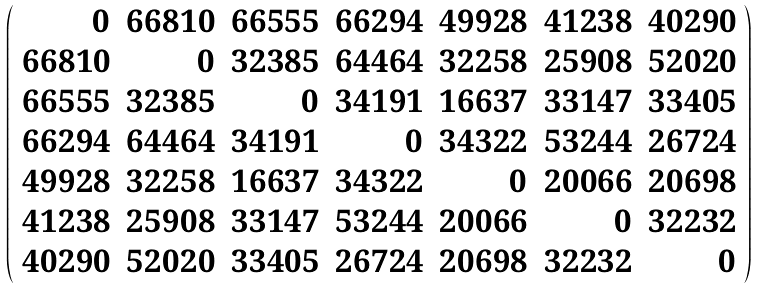Convert formula to latex. <formula><loc_0><loc_0><loc_500><loc_500>\left ( \begin{array} { r r r r r r r } 0 & 6 6 8 1 0 & 6 6 5 5 5 & 6 6 2 9 4 & 4 9 9 2 8 & 4 1 2 3 8 & 4 0 2 9 0 \\ 6 6 8 1 0 & 0 & 3 2 3 8 5 & 6 4 4 6 4 & 3 2 2 5 8 & 2 5 9 0 8 & 5 2 0 2 0 \\ 6 6 5 5 5 & 3 2 3 8 5 & 0 & 3 4 1 9 1 & 1 6 6 3 7 & 3 3 1 4 7 & 3 3 4 0 5 \\ 6 6 2 9 4 & 6 4 4 6 4 & 3 4 1 9 1 & 0 & 3 4 3 2 2 & 5 3 2 4 4 & 2 6 7 2 4 \\ 4 9 9 2 8 & 3 2 2 5 8 & 1 6 6 3 7 & 3 4 3 2 2 & 0 & 2 0 0 6 6 & 2 0 6 9 8 \\ 4 1 2 3 8 & 2 5 9 0 8 & 3 3 1 4 7 & 5 3 2 4 4 & 2 0 0 6 6 & 0 & 3 2 2 3 2 \\ 4 0 2 9 0 & 5 2 0 2 0 & 3 3 4 0 5 & 2 6 7 2 4 & 2 0 6 9 8 & 3 2 2 3 2 & 0 \end{array} \right )</formula> 